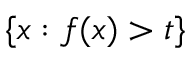Convert formula to latex. <formula><loc_0><loc_0><loc_500><loc_500>\{ x \colon f ( x ) > t \}</formula> 